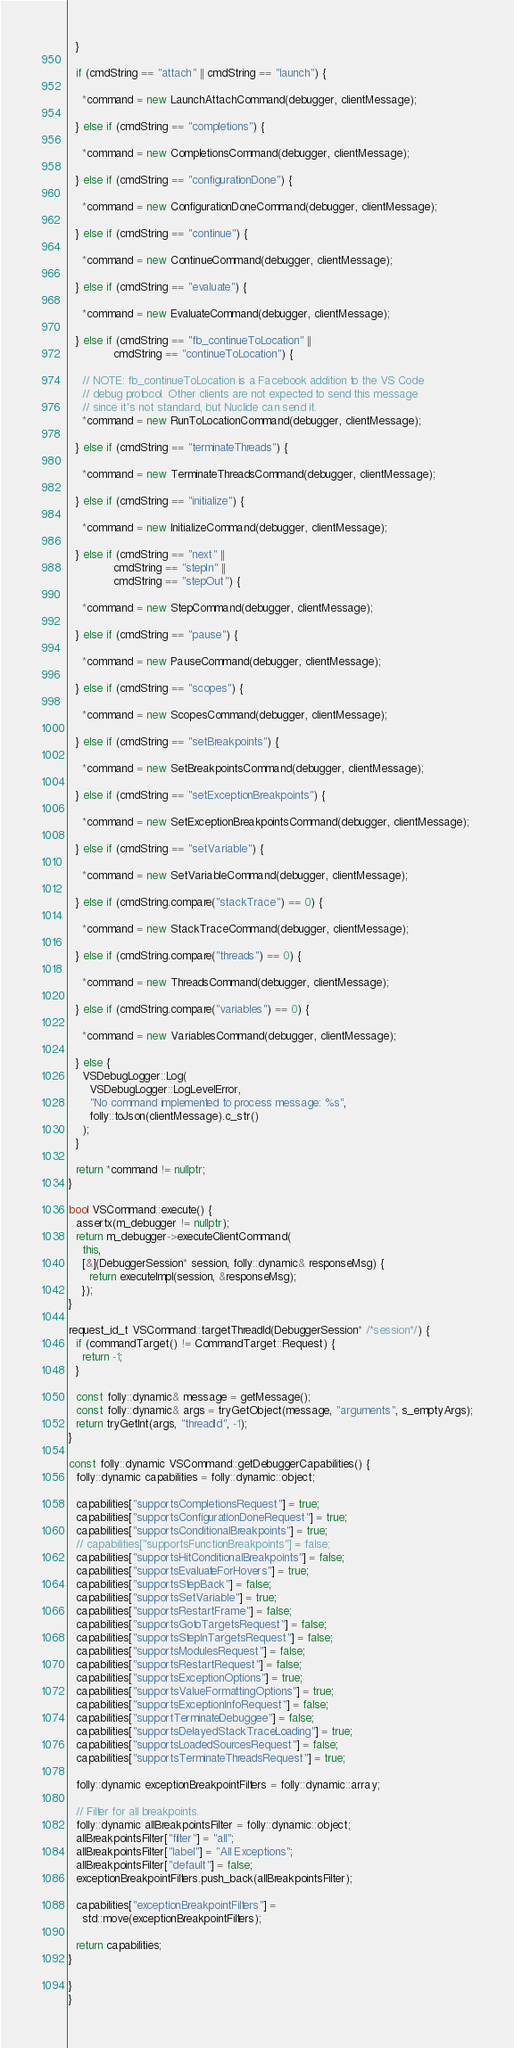Convert code to text. <code><loc_0><loc_0><loc_500><loc_500><_C++_>  }

  if (cmdString == "attach" || cmdString == "launch") {

    *command = new LaunchAttachCommand(debugger, clientMessage);

  } else if (cmdString == "completions") {

    *command = new CompletionsCommand(debugger, clientMessage);

  } else if (cmdString == "configurationDone") {

    *command = new ConfigurationDoneCommand(debugger, clientMessage);

  } else if (cmdString == "continue") {

    *command = new ContinueCommand(debugger, clientMessage);

  } else if (cmdString == "evaluate") {

    *command = new EvaluateCommand(debugger, clientMessage);

  } else if (cmdString == "fb_continueToLocation" ||
             cmdString == "continueToLocation") {

    // NOTE: fb_continueToLocation is a Facebook addition to the VS Code
    // debug protocol. Other clients are not expected to send this message
    // since it's not standard, but Nuclide can send it.
    *command = new RunToLocationCommand(debugger, clientMessage);

  } else if (cmdString == "terminateThreads") {

    *command = new TerminateThreadsCommand(debugger, clientMessage);

  } else if (cmdString == "initialize") {

    *command = new InitializeCommand(debugger, clientMessage);

  } else if (cmdString == "next" ||
             cmdString == "stepIn" ||
             cmdString == "stepOut") {

    *command = new StepCommand(debugger, clientMessage);

  } else if (cmdString == "pause") {

    *command = new PauseCommand(debugger, clientMessage);

  } else if (cmdString == "scopes") {

    *command = new ScopesCommand(debugger, clientMessage);

  } else if (cmdString == "setBreakpoints") {

    *command = new SetBreakpointsCommand(debugger, clientMessage);

  } else if (cmdString == "setExceptionBreakpoints") {

    *command = new SetExceptionBreakpointsCommand(debugger, clientMessage);

  } else if (cmdString == "setVariable") {

    *command = new SetVariableCommand(debugger, clientMessage);

  } else if (cmdString.compare("stackTrace") == 0) {

    *command = new StackTraceCommand(debugger, clientMessage);

  } else if (cmdString.compare("threads") == 0) {

    *command = new ThreadsCommand(debugger, clientMessage);

  } else if (cmdString.compare("variables") == 0) {

    *command = new VariablesCommand(debugger, clientMessage);

  } else {
    VSDebugLogger::Log(
      VSDebugLogger::LogLevelError,
      "No command implemented to process message: %s",
      folly::toJson(clientMessage).c_str()
    );
  }

  return *command != nullptr;
}

bool VSCommand::execute() {
  assertx(m_debugger != nullptr);
  return m_debugger->executeClientCommand(
    this,
    [&](DebuggerSession* session, folly::dynamic& responseMsg) {
      return executeImpl(session, &responseMsg);
    });
}

request_id_t VSCommand::targetThreadId(DebuggerSession* /*session*/) {
  if (commandTarget() != CommandTarget::Request) {
    return -1;
  }

  const folly::dynamic& message = getMessage();
  const folly::dynamic& args = tryGetObject(message, "arguments", s_emptyArgs);
  return tryGetInt(args, "threadId", -1);
}

const folly::dynamic VSCommand::getDebuggerCapabilities() {
  folly::dynamic capabilities = folly::dynamic::object;

  capabilities["supportsCompletionsRequest"] = true;
  capabilities["supportsConfigurationDoneRequest"] = true;
  capabilities["supportsConditionalBreakpoints"] = true;
  // capabilities["supportsFunctionBreakpoints"] = false;
  capabilities["supportsHitConditionalBreakpoints"] = false;
  capabilities["supportsEvaluateForHovers"] = true;
  capabilities["supportsStepBack"] = false;
  capabilities["supportsSetVariable"] = true;
  capabilities["supportsRestartFrame"] = false;
  capabilities["supportsGotoTargetsRequest"] = false;
  capabilities["supportsStepInTargetsRequest"] = false;
  capabilities["supportsModulesRequest"] = false;
  capabilities["supportsRestartRequest"] = false;
  capabilities["supportsExceptionOptions"] = true;
  capabilities["supportsValueFormattingOptions"] = true;
  capabilities["supportsExceptionInfoRequest"] = false;
  capabilities["supportTerminateDebuggee"] = false;
  capabilities["supportsDelayedStackTraceLoading"] = true;
  capabilities["supportsLoadedSourcesRequest"] = false;
  capabilities["supportsTerminateThreadsRequest"] = true;

  folly::dynamic exceptionBreakpointFilters = folly::dynamic::array;

  // Filter for all breakpoints.
  folly::dynamic allBreakpointsFilter = folly::dynamic::object;
  allBreakpointsFilter["filter"] = "all";
  allBreakpointsFilter["label"] = "All Exceptions";
  allBreakpointsFilter["default"] = false;
  exceptionBreakpointFilters.push_back(allBreakpointsFilter);

  capabilities["exceptionBreakpointFilters"] =
    std::move(exceptionBreakpointFilters);

  return capabilities;
}

}
}
</code> 